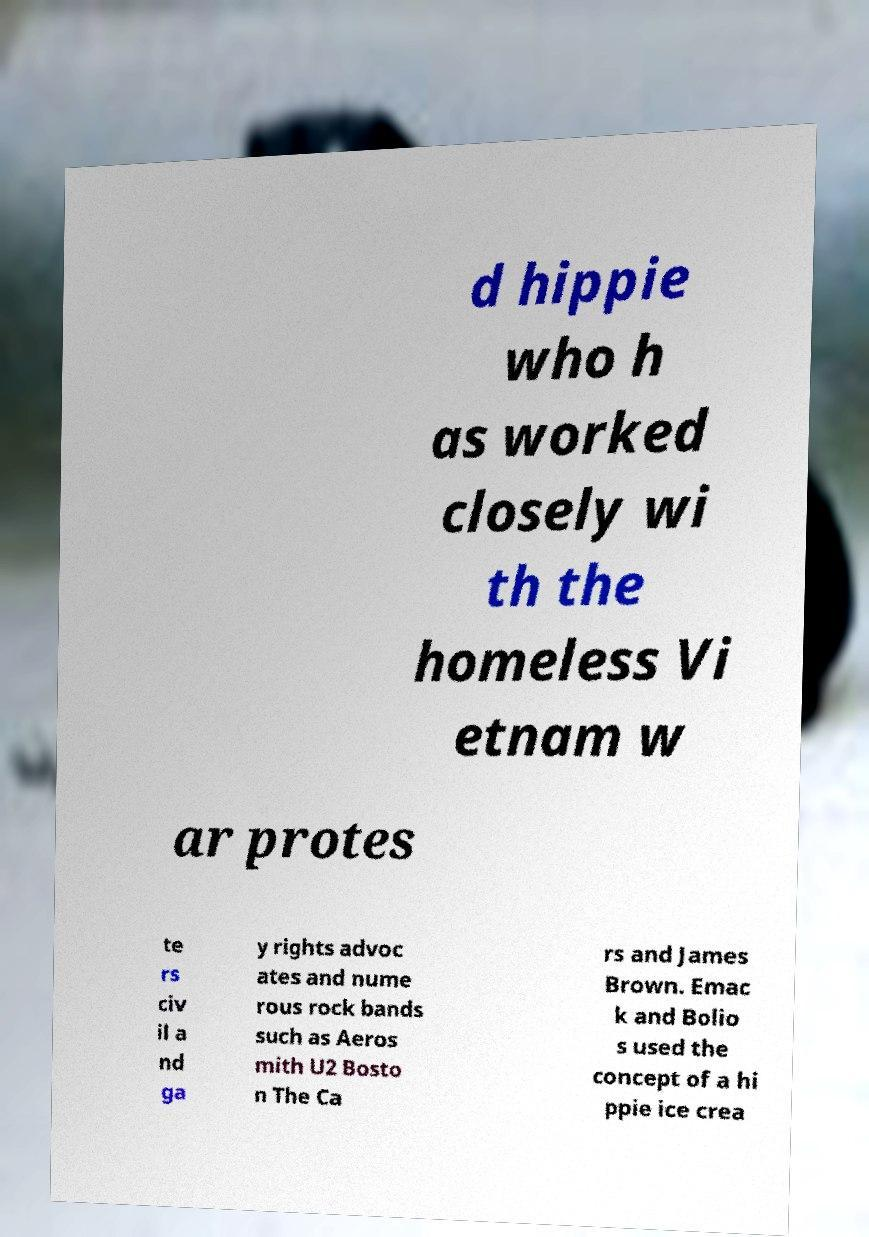Please identify and transcribe the text found in this image. d hippie who h as worked closely wi th the homeless Vi etnam w ar protes te rs civ il a nd ga y rights advoc ates and nume rous rock bands such as Aeros mith U2 Bosto n The Ca rs and James Brown. Emac k and Bolio s used the concept of a hi ppie ice crea 